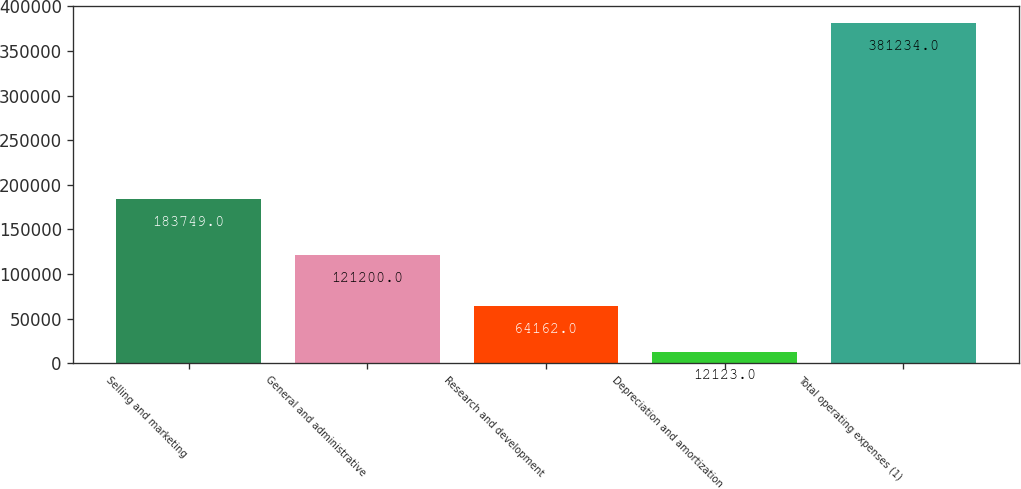<chart> <loc_0><loc_0><loc_500><loc_500><bar_chart><fcel>Selling and marketing<fcel>General and administrative<fcel>Research and development<fcel>Depreciation and amortization<fcel>Total operating expenses (1)<nl><fcel>183749<fcel>121200<fcel>64162<fcel>12123<fcel>381234<nl></chart> 